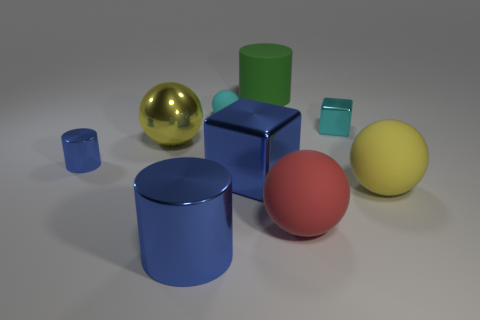Subtract all cyan balls. How many balls are left? 3 Subtract 1 cylinders. How many cylinders are left? 2 Subtract all green balls. Subtract all brown cylinders. How many balls are left? 4 Add 1 balls. How many objects exist? 10 Subtract all cubes. How many objects are left? 7 Subtract 0 gray cylinders. How many objects are left? 9 Subtract all small matte balls. Subtract all metal blocks. How many objects are left? 6 Add 9 matte cylinders. How many matte cylinders are left? 10 Add 6 big rubber cylinders. How many big rubber cylinders exist? 7 